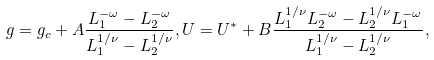<formula> <loc_0><loc_0><loc_500><loc_500>g = g _ { c } + A \frac { L _ { 1 } ^ { - \omega } - L _ { 2 } ^ { - \omega } } { L _ { 1 } ^ { 1 / \nu } - L _ { 2 } ^ { 1 / \nu } } , U = U ^ { * } + B \frac { L _ { 1 } ^ { 1 / \nu } L _ { 2 } ^ { - \omega } - L _ { 2 } ^ { 1 / \nu } L _ { 1 } ^ { - \omega } } { L _ { 1 } ^ { 1 / \nu } - L _ { 2 } ^ { 1 / \nu } } ,</formula> 